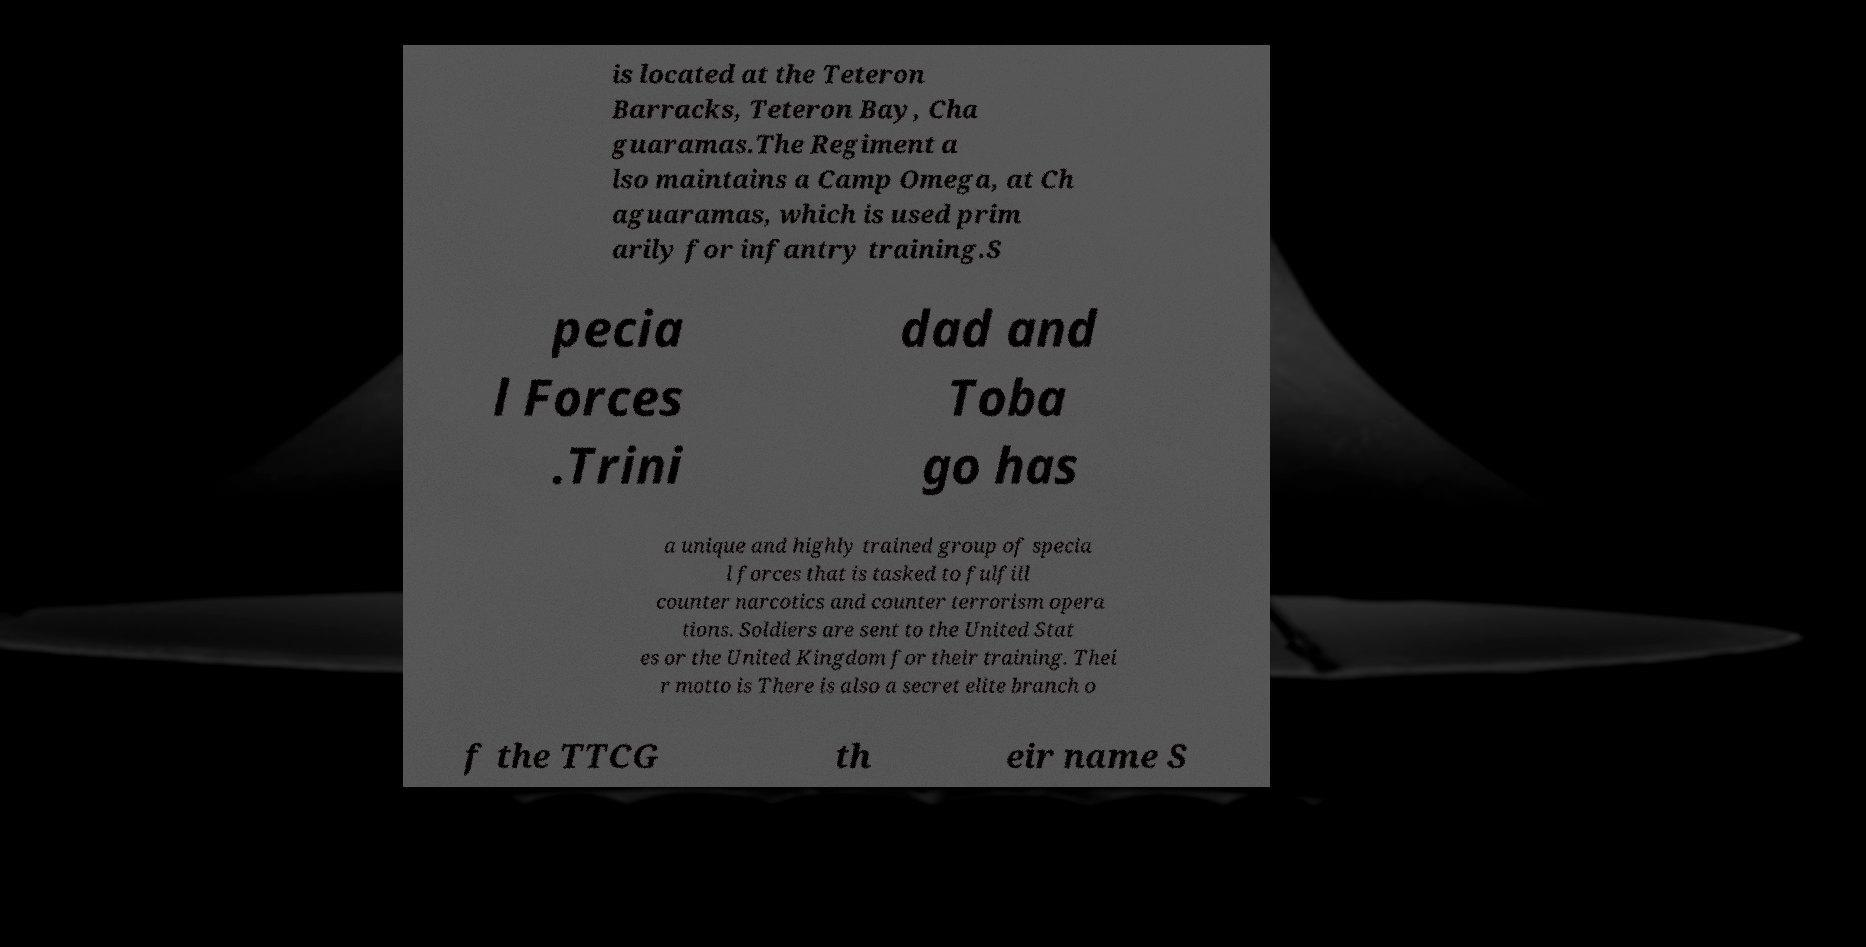Could you extract and type out the text from this image? is located at the Teteron Barracks, Teteron Bay, Cha guaramas.The Regiment a lso maintains a Camp Omega, at Ch aguaramas, which is used prim arily for infantry training.S pecia l Forces .Trini dad and Toba go has a unique and highly trained group of specia l forces that is tasked to fulfill counter narcotics and counter terrorism opera tions. Soldiers are sent to the United Stat es or the United Kingdom for their training. Thei r motto is There is also a secret elite branch o f the TTCG th eir name S 